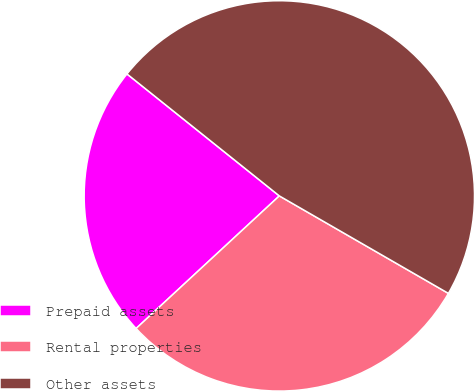Convert chart to OTSL. <chart><loc_0><loc_0><loc_500><loc_500><pie_chart><fcel>Prepaid assets<fcel>Rental properties<fcel>Other assets<nl><fcel>22.63%<fcel>29.79%<fcel>47.58%<nl></chart> 